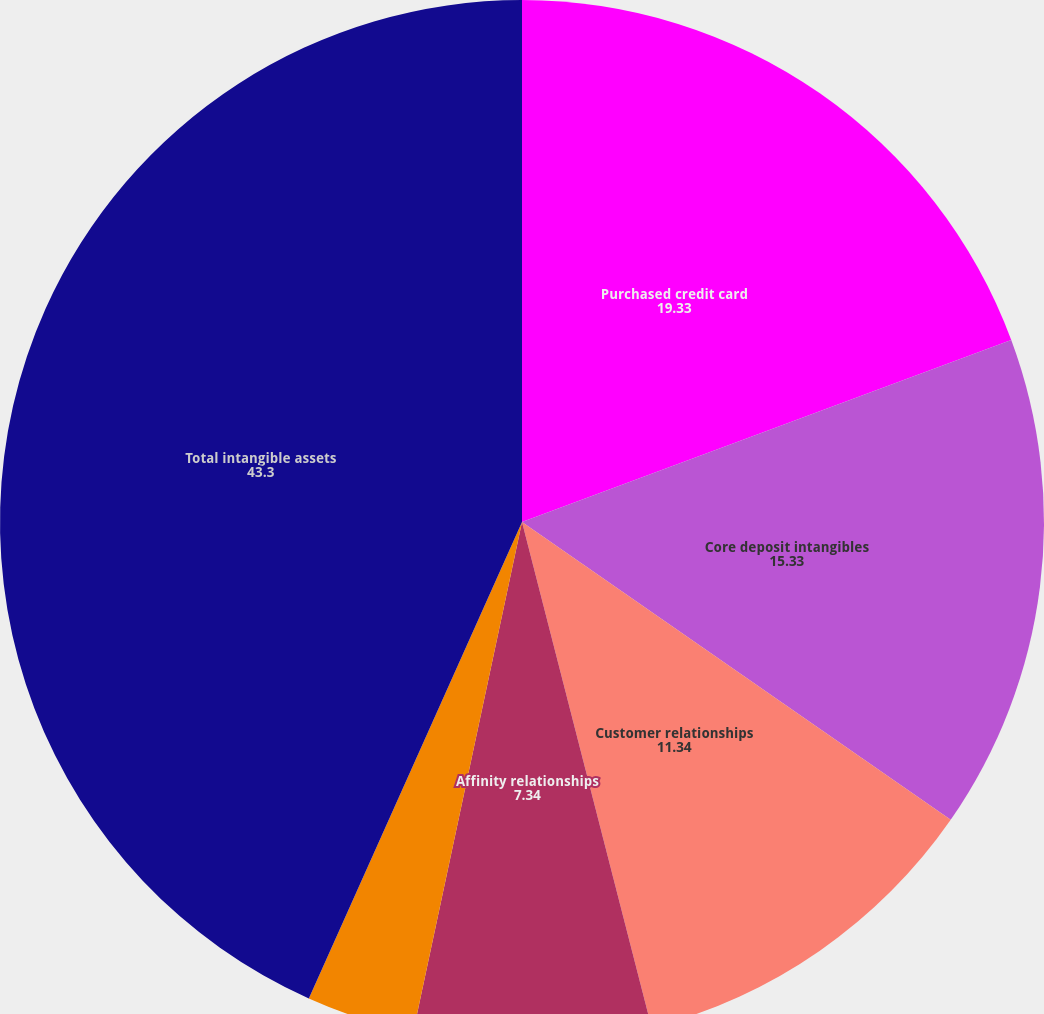<chart> <loc_0><loc_0><loc_500><loc_500><pie_chart><fcel>Purchased credit card<fcel>Core deposit intangibles<fcel>Customer relationships<fcel>Affinity relationships<fcel>Other intangibles<fcel>Total intangible assets<nl><fcel>19.33%<fcel>15.33%<fcel>11.34%<fcel>7.34%<fcel>3.35%<fcel>43.3%<nl></chart> 